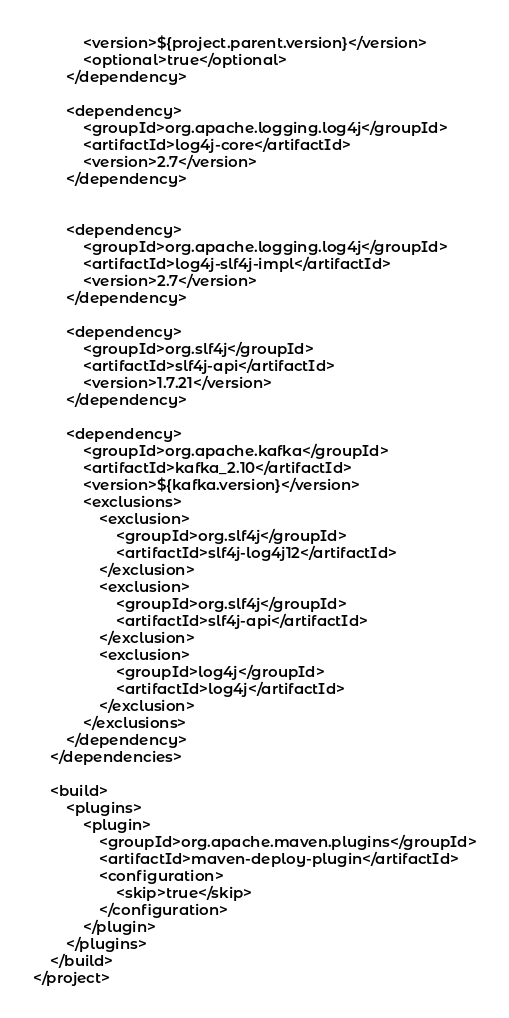Convert code to text. <code><loc_0><loc_0><loc_500><loc_500><_XML_>			<version>${project.parent.version}</version>
			<optional>true</optional>
		</dependency>
		
		<dependency>
			<groupId>org.apache.logging.log4j</groupId>
			<artifactId>log4j-core</artifactId>
			<version>2.7</version>
		</dependency>


		<dependency>
			<groupId>org.apache.logging.log4j</groupId>
			<artifactId>log4j-slf4j-impl</artifactId>
			<version>2.7</version>
		</dependency>

		<dependency>
			<groupId>org.slf4j</groupId>
			<artifactId>slf4j-api</artifactId>
			<version>1.7.21</version>
		</dependency>

		<dependency>
			<groupId>org.apache.kafka</groupId>
			<artifactId>kafka_2.10</artifactId>
			<version>${kafka.version}</version>
			<exclusions>
				<exclusion>
					<groupId>org.slf4j</groupId>
					<artifactId>slf4j-log4j12</artifactId>
				</exclusion>
				<exclusion>
					<groupId>org.slf4j</groupId>
					<artifactId>slf4j-api</artifactId>
				</exclusion>
				<exclusion>
					<groupId>log4j</groupId>
					<artifactId>log4j</artifactId>
				</exclusion>
			</exclusions>
		</dependency>
	</dependencies>

	<build>
		<plugins>
			<plugin>
				<groupId>org.apache.maven.plugins</groupId>
				<artifactId>maven-deploy-plugin</artifactId>
				<configuration>
					<skip>true</skip>
				</configuration>
			</plugin>
		</plugins>
	</build>
</project></code> 